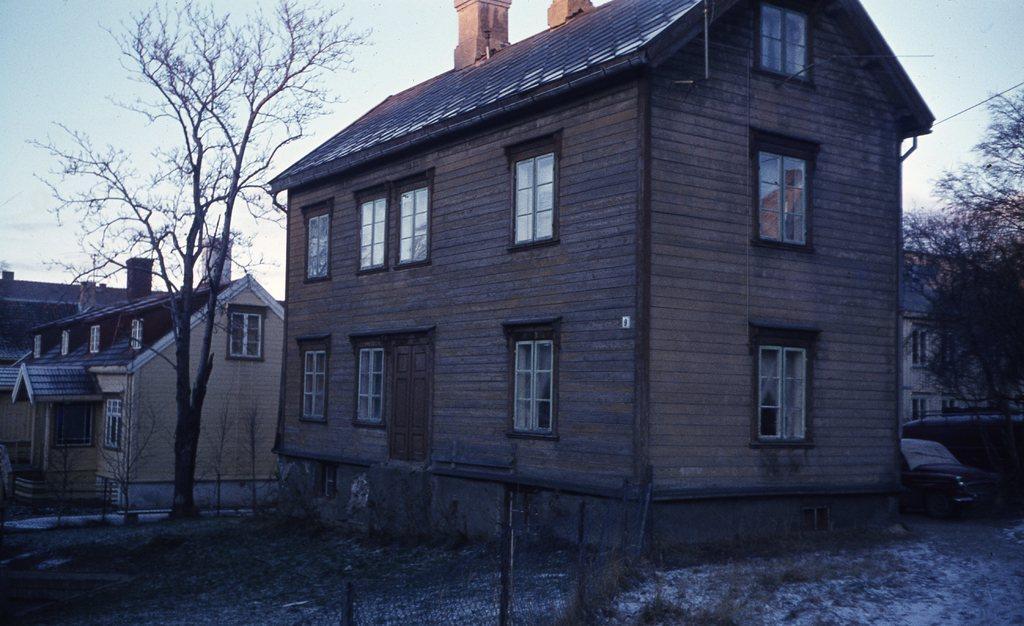Could you give a brief overview of what you see in this image? In this image, I can see the houses and trees. At the bottom of the image, I can see a fence, snow and grass. On the right side of the image, there are vehicles. In the background, there is the sky. 